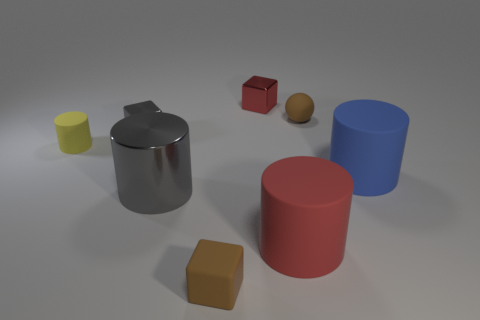What do you think the significance of the arrangement of these objects might be? The arrangement seems random, suggesting that the purpose may be to showcase a variety of shapes and colors. Such an arrangement could be used to study the properties of light and shadow, or for a visual exercise in geometric shapes and form recognition. Could these objects be representative of something else, perhaps conceptually or symbolically? It's possible to interpret the objects as symbols due to their basic geometric shapes. For example, the cube might represent stability and order, the spheres could signify unity and completeness, while the cylinders might symbolize efficiency. However, without more context, it's primarily a speculative interpretation. 